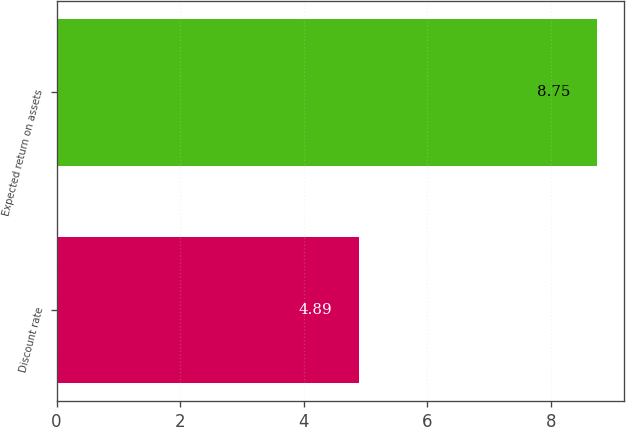Convert chart. <chart><loc_0><loc_0><loc_500><loc_500><bar_chart><fcel>Discount rate<fcel>Expected return on assets<nl><fcel>4.89<fcel>8.75<nl></chart> 